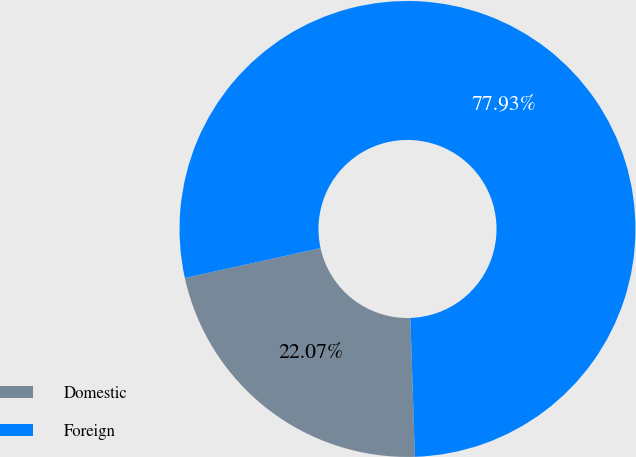Convert chart. <chart><loc_0><loc_0><loc_500><loc_500><pie_chart><fcel>Domestic<fcel>Foreign<nl><fcel>22.07%<fcel>77.93%<nl></chart> 